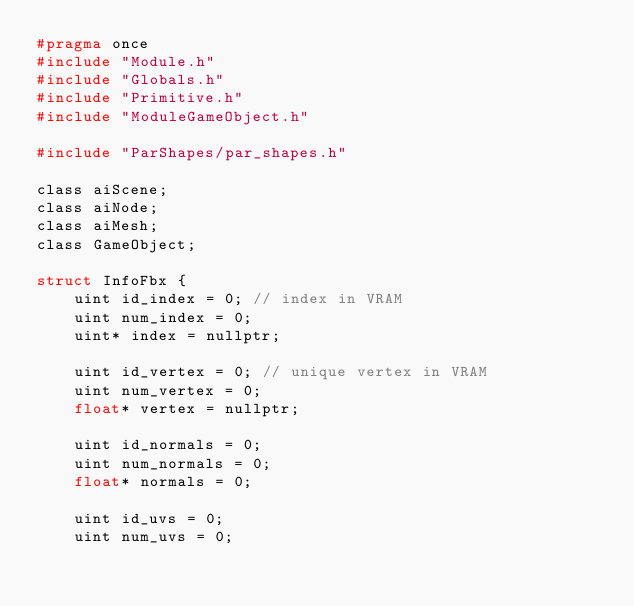<code> <loc_0><loc_0><loc_500><loc_500><_C_>#pragma once
#include "Module.h"
#include "Globals.h"
#include "Primitive.h"	
#include "ModuleGameObject.h"

#include "ParShapes/par_shapes.h"

class aiScene;
class aiNode;
class aiMesh;
class GameObject;

struct InfoFbx {
	uint id_index = 0; // index in VRAM
	uint num_index = 0;
	uint* index = nullptr;

	uint id_vertex = 0; // unique vertex in VRAM
	uint num_vertex = 0;
	float* vertex = nullptr;

	uint id_normals = 0;
	uint num_normals = 0;
	float* normals = 0;

	uint id_uvs = 0;
	uint num_uvs = 0;</code> 